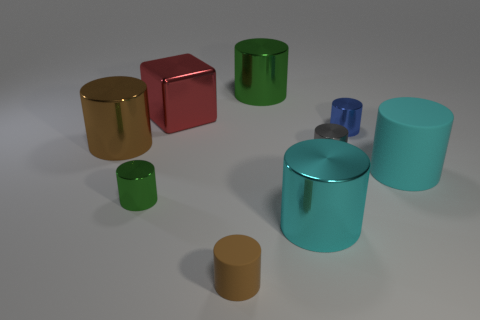How does the lighting affect the appearance of the objects? The lighting in the image is soft and diffuse, creating subtle shadows and highlights that enhance the contours of each object. It gives the scene a calm and balanced ambiance, while also emphasizing the reflective qualities of the materials. 